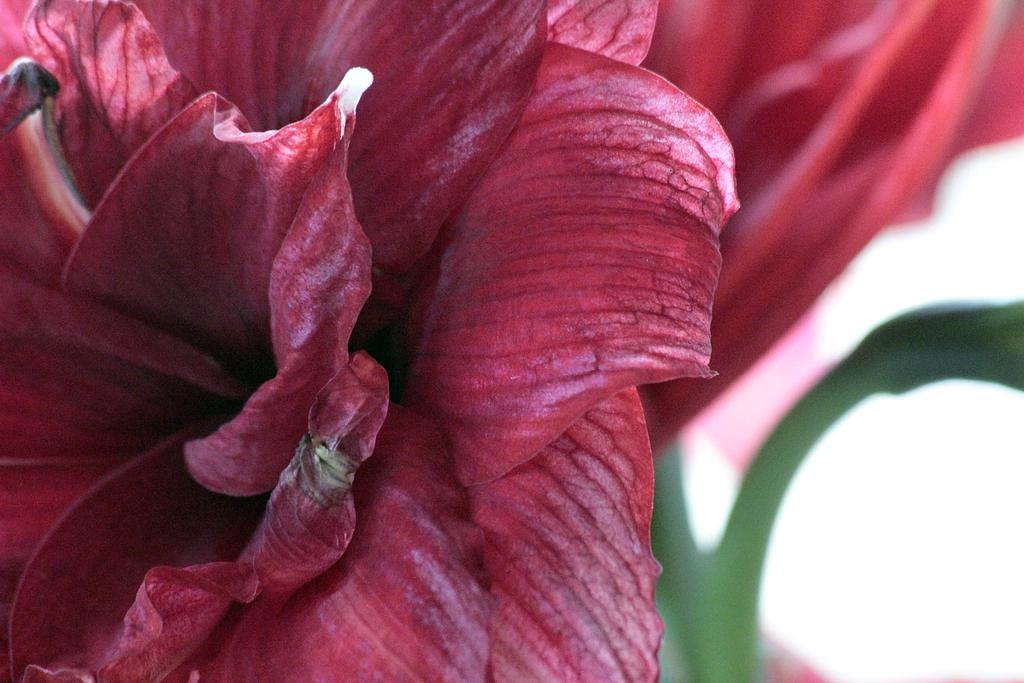What is the main subject of the image? There is a flower in the image. What color is the background of the image? The background of the image is white. How many passengers are visible on the yak in the image? There is no yak or passengers present in the image; it features a flower with a white background. 